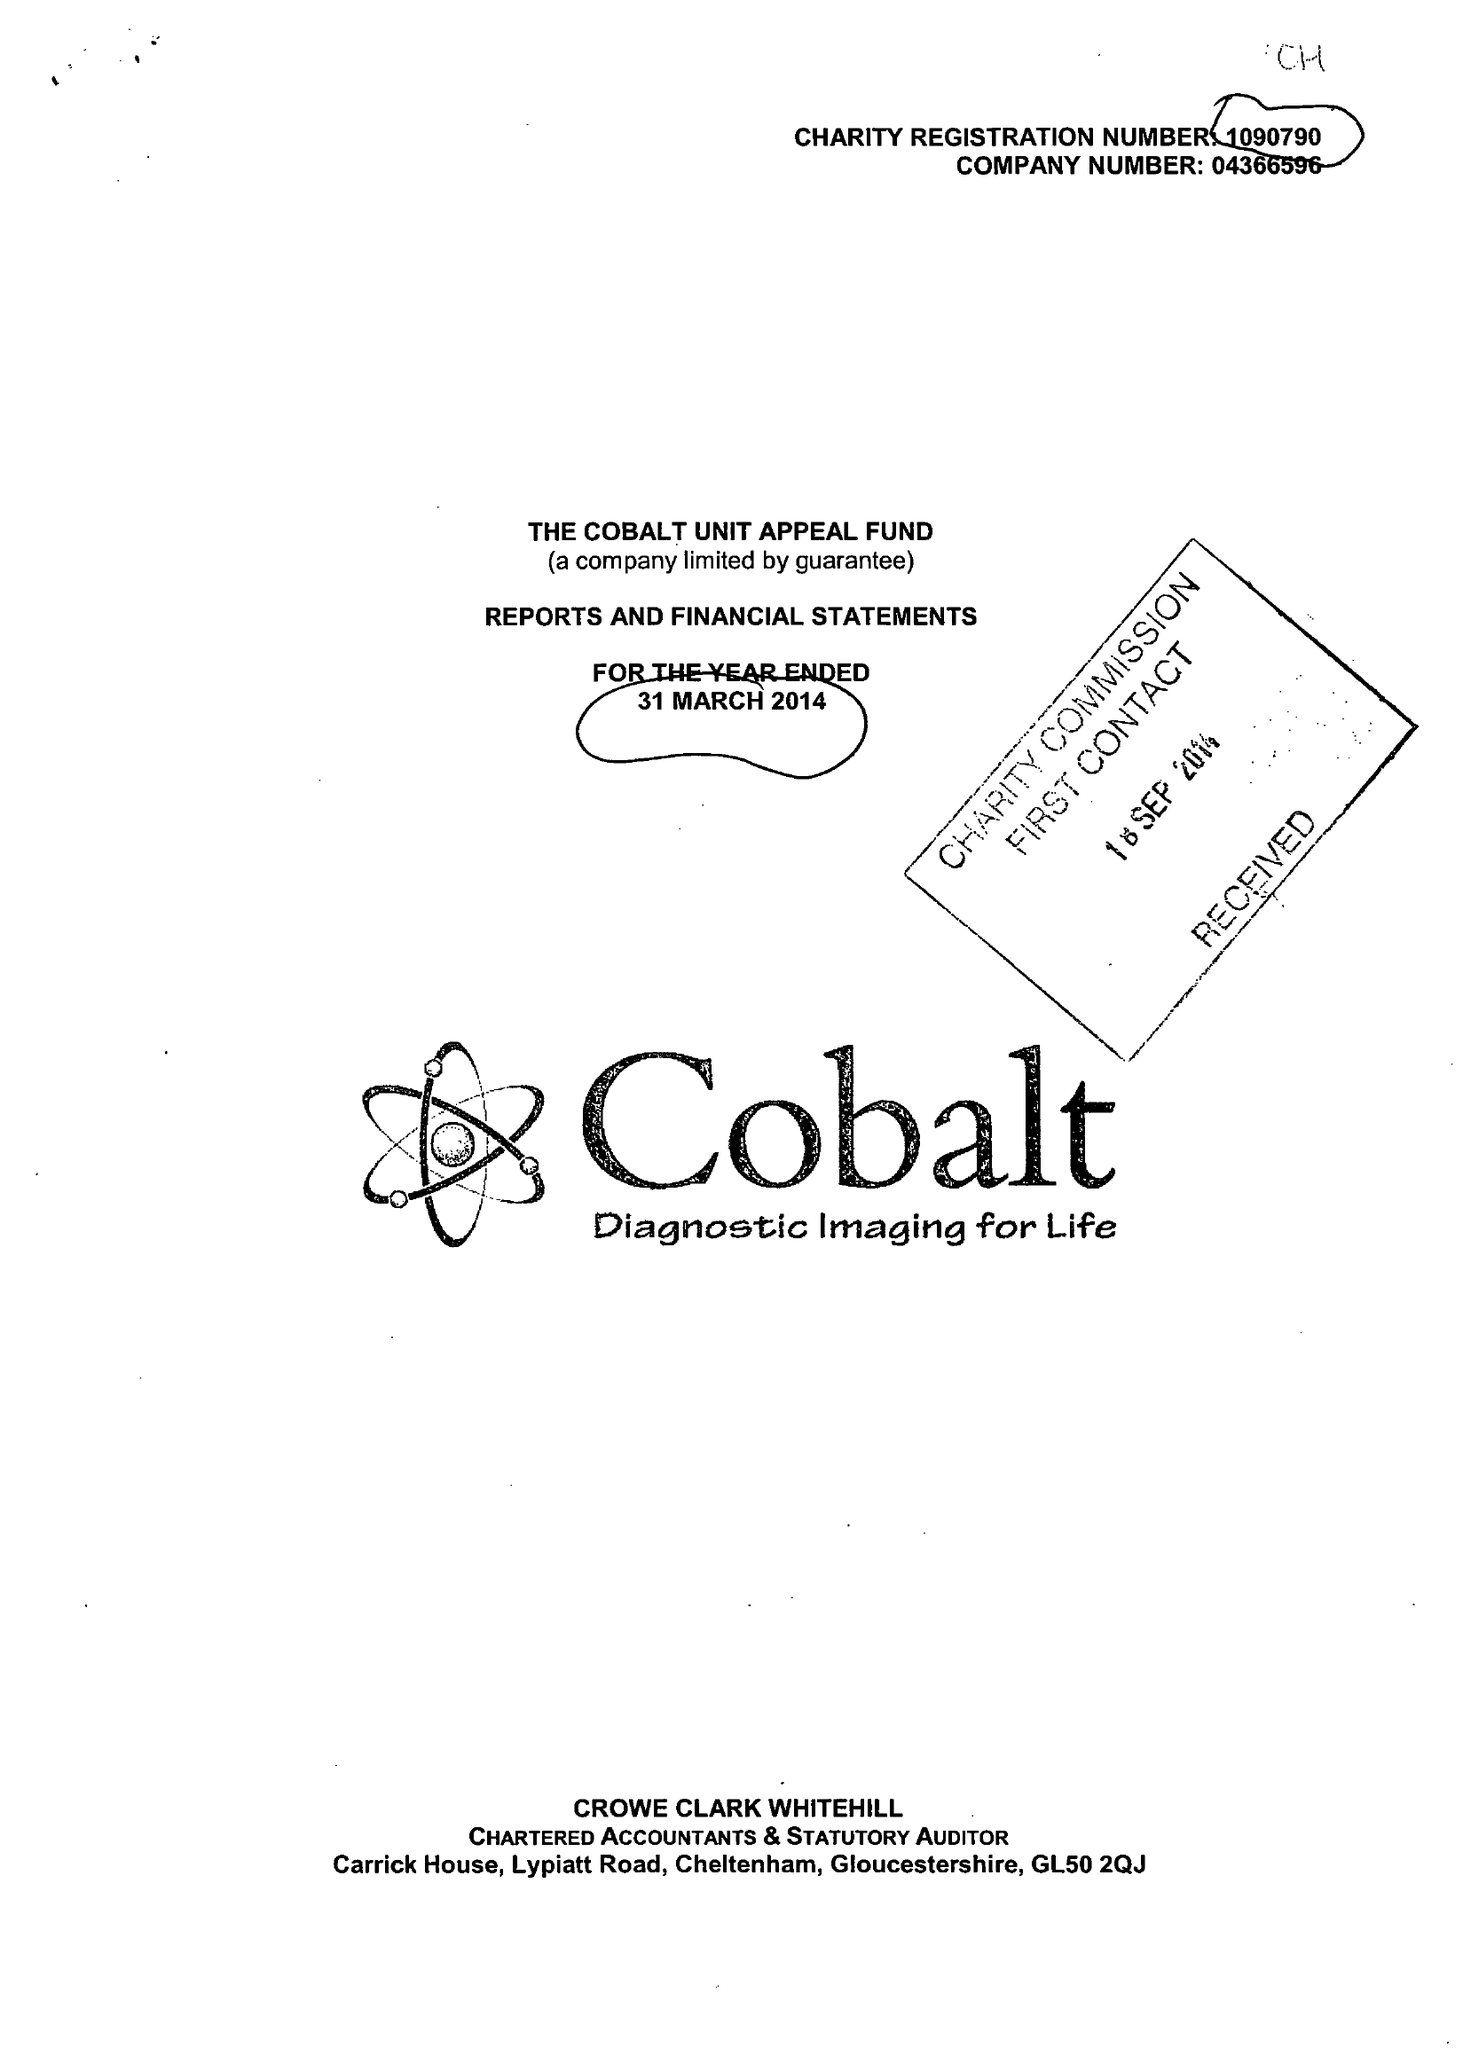What is the value for the spending_annually_in_british_pounds?
Answer the question using a single word or phrase. 6856349.00 